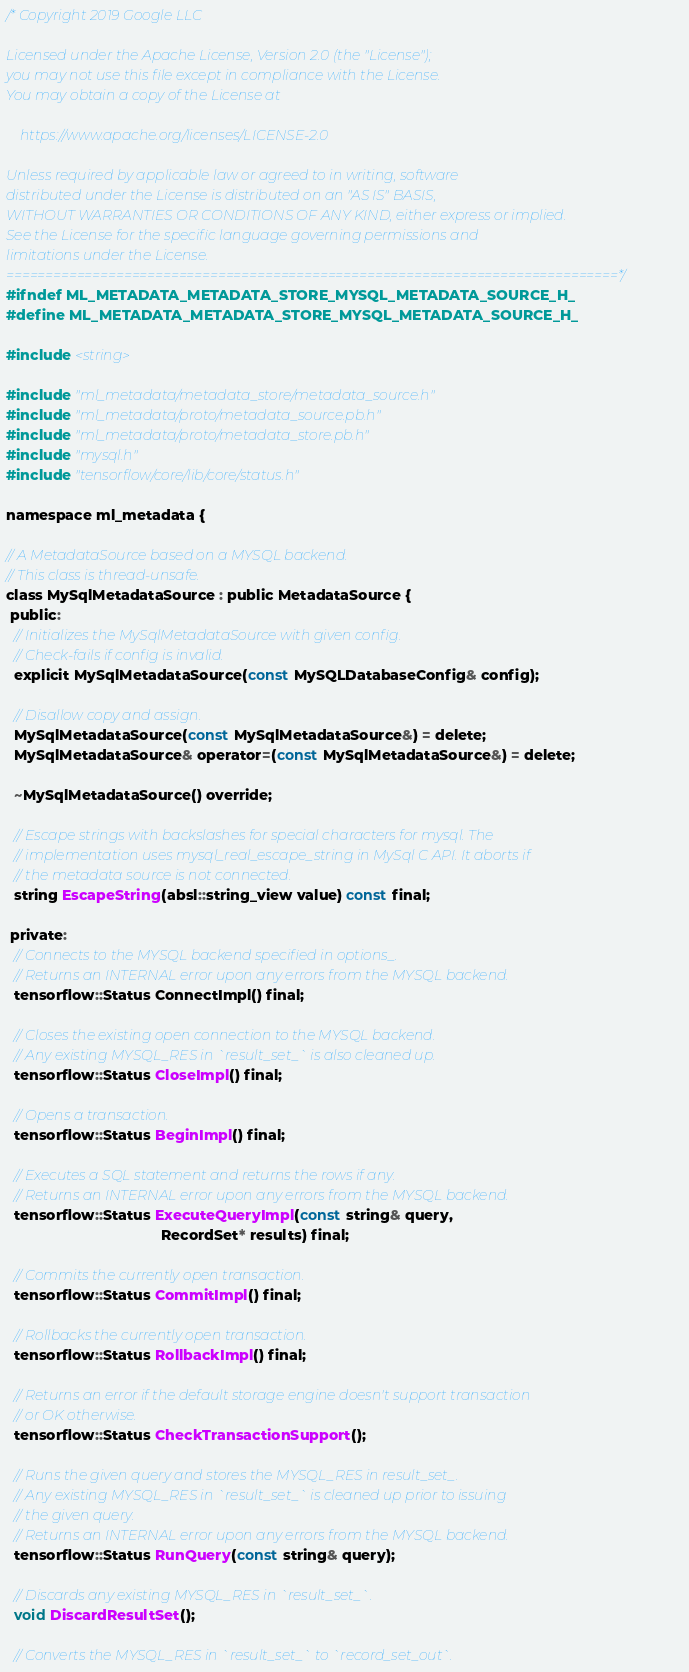Convert code to text. <code><loc_0><loc_0><loc_500><loc_500><_C_>/* Copyright 2019 Google LLC

Licensed under the Apache License, Version 2.0 (the "License");
you may not use this file except in compliance with the License.
You may obtain a copy of the License at

    https://www.apache.org/licenses/LICENSE-2.0

Unless required by applicable law or agreed to in writing, software
distributed under the License is distributed on an "AS IS" BASIS,
WITHOUT WARRANTIES OR CONDITIONS OF ANY KIND, either express or implied.
See the License for the specific language governing permissions and
limitations under the License.
==============================================================================*/
#ifndef ML_METADATA_METADATA_STORE_MYSQL_METADATA_SOURCE_H_
#define ML_METADATA_METADATA_STORE_MYSQL_METADATA_SOURCE_H_

#include <string>

#include "ml_metadata/metadata_store/metadata_source.h"
#include "ml_metadata/proto/metadata_source.pb.h"
#include "ml_metadata/proto/metadata_store.pb.h"
#include "mysql.h"
#include "tensorflow/core/lib/core/status.h"

namespace ml_metadata {

// A MetadataSource based on a MYSQL backend.
// This class is thread-unsafe.
class MySqlMetadataSource : public MetadataSource {
 public:
  // Initializes the MySqlMetadataSource with given config.
  // Check-fails if config is invalid.
  explicit MySqlMetadataSource(const MySQLDatabaseConfig& config);

  // Disallow copy and assign.
  MySqlMetadataSource(const MySqlMetadataSource&) = delete;
  MySqlMetadataSource& operator=(const MySqlMetadataSource&) = delete;

  ~MySqlMetadataSource() override;

  // Escape strings with backslashes for special characters for mysql. The
  // implementation uses mysql_real_escape_string in MySql C API. It aborts if
  // the metadata source is not connected.
  string EscapeString(absl::string_view value) const final;

 private:
  // Connects to the MYSQL backend specified in options_.
  // Returns an INTERNAL error upon any errors from the MYSQL backend.
  tensorflow::Status ConnectImpl() final;

  // Closes the existing open connection to the MYSQL backend.
  // Any existing MYSQL_RES in `result_set_` is also cleaned up.
  tensorflow::Status CloseImpl() final;

  // Opens a transaction.
  tensorflow::Status BeginImpl() final;

  // Executes a SQL statement and returns the rows if any.
  // Returns an INTERNAL error upon any errors from the MYSQL backend.
  tensorflow::Status ExecuteQueryImpl(const string& query,
                                      RecordSet* results) final;

  // Commits the currently open transaction.
  tensorflow::Status CommitImpl() final;

  // Rollbacks the currently open transaction.
  tensorflow::Status RollbackImpl() final;

  // Returns an error if the default storage engine doesn't support transaction
  // or OK otherwise.
  tensorflow::Status CheckTransactionSupport();

  // Runs the given query and stores the MYSQL_RES in result_set_.
  // Any existing MYSQL_RES in `result_set_` is cleaned up prior to issuing
  // the given query.
  // Returns an INTERNAL error upon any errors from the MYSQL backend.
  tensorflow::Status RunQuery(const string& query);

  // Discards any existing MYSQL_RES in `result_set_`.
  void DiscardResultSet();

  // Converts the MYSQL_RES in `result_set_` to `record_set_out`.</code> 